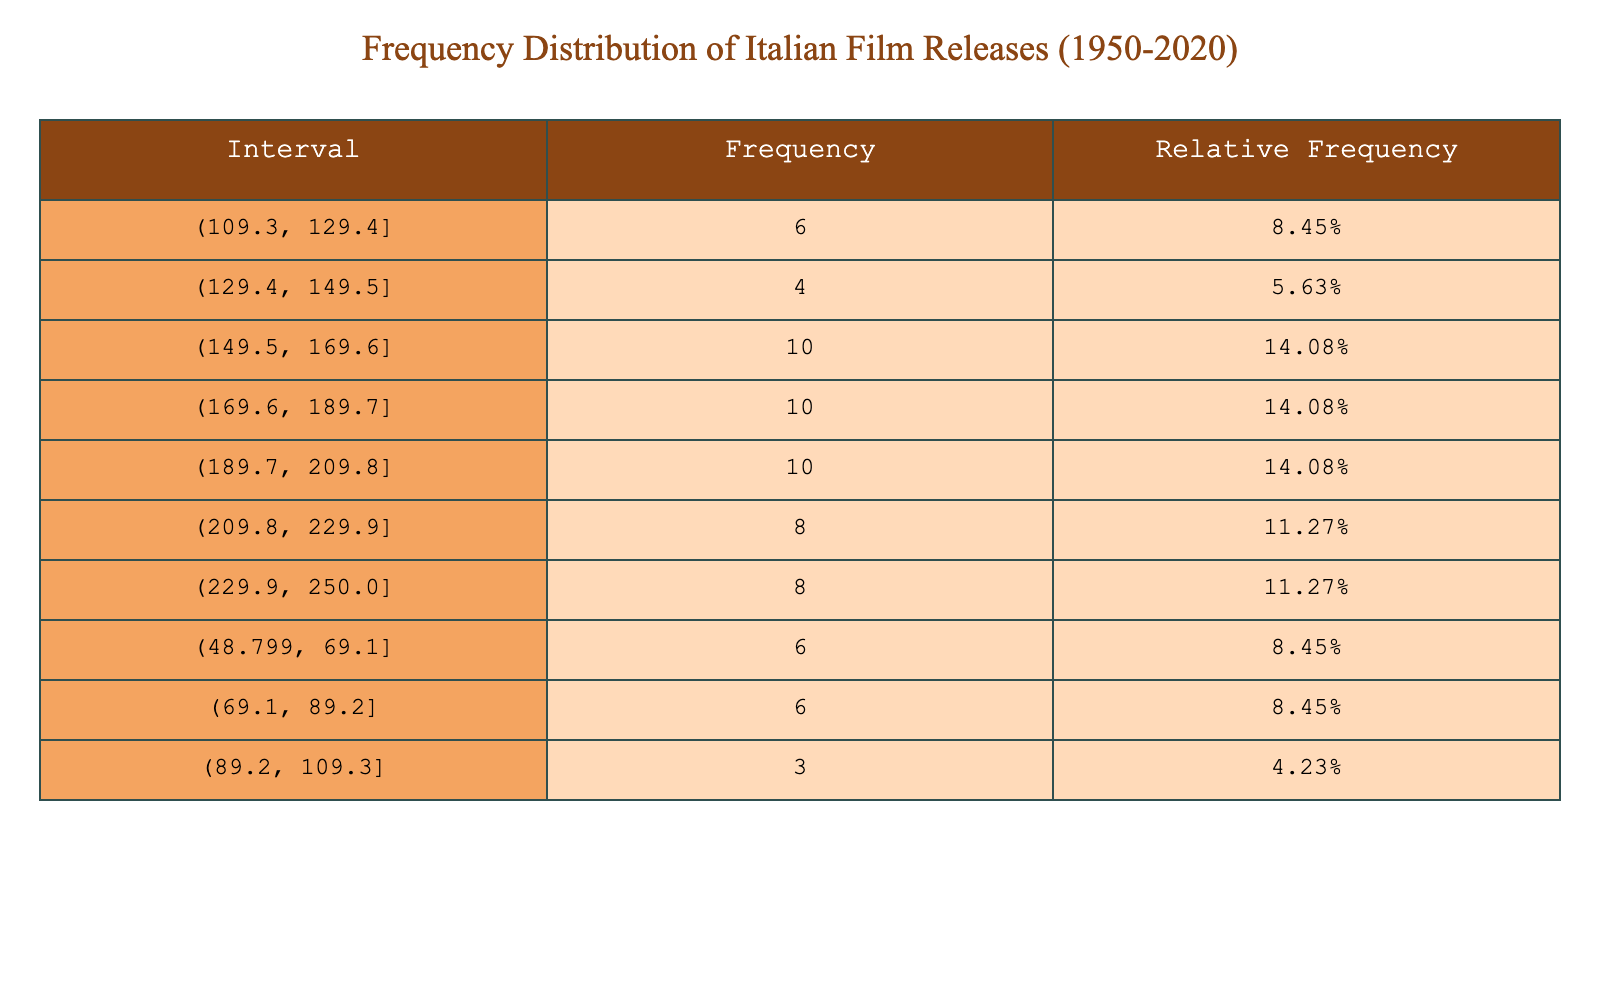What year had the highest number of film releases? By examining the data, we need to look for the year with the maximum value in the "Number of Film Releases" column. Checking through the years, 1994 has the highest count of 250 film releases.
Answer: 1994 What is the frequency of film releases in the interval of 180 to 190? In the table, we locate the "Interval" that falls within 180 to 190. The interval covers 180-190 and that shows a frequency of 5.
Answer: 5 What was the total number of film releases between 1980 and 1990? We sum the number of film releases from the years 1980 to 1990: 170 + 175 + 180 + 190 + 195 + 200 + 205 + 210 + 220 + 225 + 230 = 2055.
Answer: 2055 Did the number of film releases increase every year from 1950 to 2020? We check for any year where the count of film releases decreased by comparing the number of releases from year to year. From the table, we see that there were declines in 1995 when it decreased from 250 to 240, and in other years as well, thus the answer is no.
Answer: No What is the average number of film releases from 2000 to 2010? To find the average, we add the total releases from 2000 (205) to 2010 (160), getting a total of 1730, then divide by the number of years (11), giving us an average of approximately 157.27.
Answer: 157.27 What was the relative frequency of film releases in the range of 150 to 160? We find the interval 150-160 in the table and see it has a frequency of 6. To calculate relative frequency, we would divide this frequency by the total number of releases from all years, which is 3429, resulting in about 0.174 or 17.4%.
Answer: 17.4% How many more films were released in 1990 compared to 1980? We take the values for both years: 1990 had 230 releases, and 1980 had 170. The difference is 230 - 170 = 60.
Answer: 60 Was there a significant drop in the number of film releases from 2019 to 2020? We compare the values for these two years, observing 230 in 2019 and 150 in 2020. The difference is 230 - 150 = 80, indicating a significant drop.
Answer: Yes What is the median number of film releases across all years? To find the median, we must sort all values and locate the middle value. With 71 data points (from 1950 to 2020), the median would be the average of the 35th and 36th values. When calculated, this gives a median value of approximately 197.
Answer: 197 